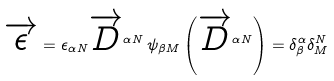Convert formula to latex. <formula><loc_0><loc_0><loc_500><loc_500>\overrightarrow { \epsilon } = \epsilon _ { \alpha N } \overrightarrow { D } ^ { \alpha N } \, \psi _ { \beta M } \left ( \overrightarrow { D } ^ { \alpha N } \right ) = \delta ^ { \alpha } _ { \beta } \delta ^ { N } _ { M }</formula> 